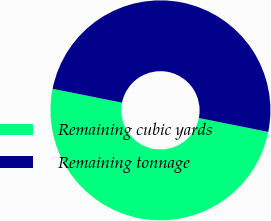<chart> <loc_0><loc_0><loc_500><loc_500><pie_chart><fcel>Remaining cubic yards<fcel>Remaining tonnage<nl><fcel>50.0%<fcel>50.0%<nl></chart> 